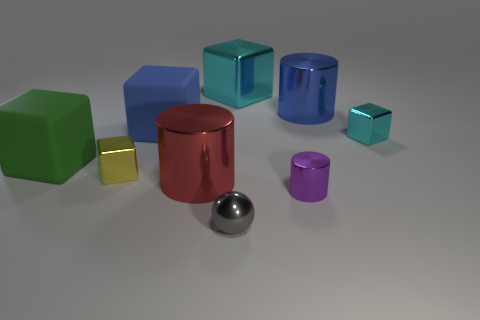Is there any other thing that is the same shape as the small gray object?
Your answer should be very brief. No. Are there any other things that are the same color as the small cylinder?
Make the answer very short. No. How many small metallic things are to the left of the big cylinder on the left side of the purple metallic thing?
Make the answer very short. 1. What is the shape of the green rubber object?
Give a very brief answer. Cube. What shape is the red object that is the same material as the small cyan thing?
Offer a very short reply. Cylinder. There is a blue object to the right of the metal ball; does it have the same shape as the red shiny object?
Provide a short and direct response. Yes. There is a tiny object that is in front of the tiny cylinder; what is its shape?
Provide a succinct answer. Sphere. There is a small metallic thing that is the same color as the large metal cube; what is its shape?
Give a very brief answer. Cube. How many purple objects are the same size as the purple cylinder?
Give a very brief answer. 0. What color is the ball?
Make the answer very short. Gray. 